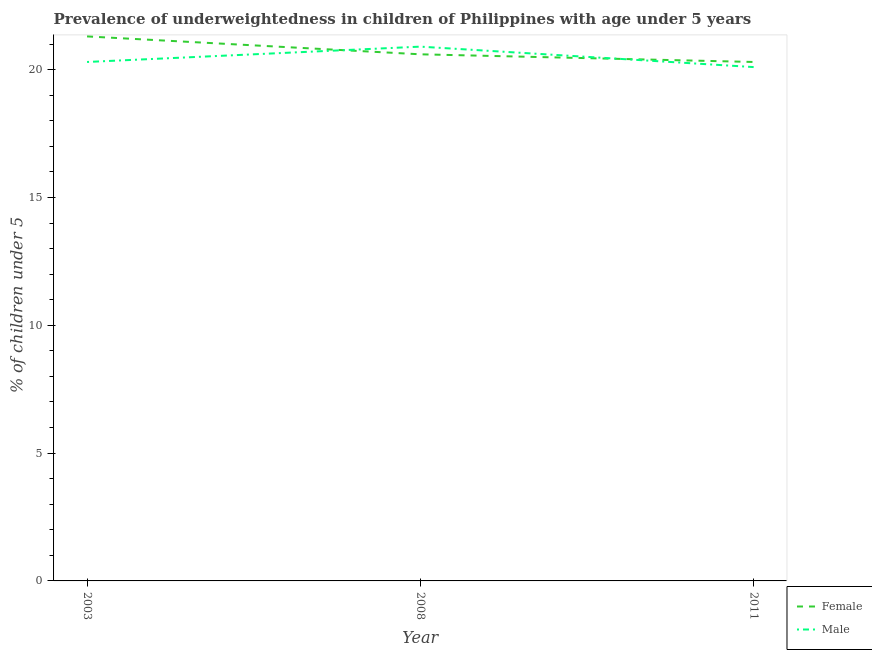How many different coloured lines are there?
Provide a short and direct response. 2. Does the line corresponding to percentage of underweighted female children intersect with the line corresponding to percentage of underweighted male children?
Your answer should be very brief. Yes. What is the percentage of underweighted female children in 2011?
Ensure brevity in your answer.  20.3. Across all years, what is the maximum percentage of underweighted female children?
Your answer should be compact. 21.3. Across all years, what is the minimum percentage of underweighted female children?
Your answer should be compact. 20.3. In which year was the percentage of underweighted female children maximum?
Your response must be concise. 2003. In which year was the percentage of underweighted female children minimum?
Your response must be concise. 2011. What is the total percentage of underweighted female children in the graph?
Give a very brief answer. 62.2. What is the difference between the percentage of underweighted male children in 2008 and that in 2011?
Provide a short and direct response. 0.8. What is the average percentage of underweighted female children per year?
Provide a succinct answer. 20.73. In the year 2008, what is the difference between the percentage of underweighted male children and percentage of underweighted female children?
Your response must be concise. 0.3. In how many years, is the percentage of underweighted female children greater than 19 %?
Your answer should be compact. 3. What is the ratio of the percentage of underweighted male children in 2003 to that in 2008?
Make the answer very short. 0.97. Is the difference between the percentage of underweighted female children in 2008 and 2011 greater than the difference between the percentage of underweighted male children in 2008 and 2011?
Provide a short and direct response. No. What is the difference between the highest and the second highest percentage of underweighted female children?
Provide a succinct answer. 0.7. What is the difference between the highest and the lowest percentage of underweighted female children?
Keep it short and to the point. 1. In how many years, is the percentage of underweighted male children greater than the average percentage of underweighted male children taken over all years?
Your answer should be very brief. 1. Is the sum of the percentage of underweighted male children in 2003 and 2011 greater than the maximum percentage of underweighted female children across all years?
Make the answer very short. Yes. Does the percentage of underweighted male children monotonically increase over the years?
Offer a terse response. No. Is the percentage of underweighted male children strictly greater than the percentage of underweighted female children over the years?
Your response must be concise. No. How many years are there in the graph?
Your response must be concise. 3. Are the values on the major ticks of Y-axis written in scientific E-notation?
Provide a short and direct response. No. Does the graph contain any zero values?
Your response must be concise. No. How many legend labels are there?
Ensure brevity in your answer.  2. What is the title of the graph?
Offer a very short reply. Prevalence of underweightedness in children of Philippines with age under 5 years. What is the label or title of the X-axis?
Keep it short and to the point. Year. What is the label or title of the Y-axis?
Make the answer very short.  % of children under 5. What is the  % of children under 5 of Female in 2003?
Make the answer very short. 21.3. What is the  % of children under 5 of Male in 2003?
Offer a terse response. 20.3. What is the  % of children under 5 of Female in 2008?
Provide a short and direct response. 20.6. What is the  % of children under 5 in Male in 2008?
Provide a succinct answer. 20.9. What is the  % of children under 5 in Female in 2011?
Offer a very short reply. 20.3. What is the  % of children under 5 in Male in 2011?
Your answer should be very brief. 20.1. Across all years, what is the maximum  % of children under 5 in Female?
Your answer should be very brief. 21.3. Across all years, what is the maximum  % of children under 5 in Male?
Provide a short and direct response. 20.9. Across all years, what is the minimum  % of children under 5 in Female?
Give a very brief answer. 20.3. Across all years, what is the minimum  % of children under 5 of Male?
Offer a very short reply. 20.1. What is the total  % of children under 5 of Female in the graph?
Ensure brevity in your answer.  62.2. What is the total  % of children under 5 of Male in the graph?
Your answer should be compact. 61.3. What is the difference between the  % of children under 5 in Female in 2003 and that in 2008?
Offer a very short reply. 0.7. What is the difference between the  % of children under 5 in Male in 2003 and that in 2008?
Make the answer very short. -0.6. What is the difference between the  % of children under 5 of Female in 2003 and that in 2011?
Your answer should be very brief. 1. What is the difference between the  % of children under 5 in Male in 2003 and that in 2011?
Your answer should be very brief. 0.2. What is the difference between the  % of children under 5 in Female in 2003 and the  % of children under 5 in Male in 2011?
Offer a very short reply. 1.2. What is the difference between the  % of children under 5 of Female in 2008 and the  % of children under 5 of Male in 2011?
Provide a succinct answer. 0.5. What is the average  % of children under 5 in Female per year?
Make the answer very short. 20.73. What is the average  % of children under 5 of Male per year?
Give a very brief answer. 20.43. In the year 2008, what is the difference between the  % of children under 5 in Female and  % of children under 5 in Male?
Provide a succinct answer. -0.3. In the year 2011, what is the difference between the  % of children under 5 in Female and  % of children under 5 in Male?
Offer a very short reply. 0.2. What is the ratio of the  % of children under 5 of Female in 2003 to that in 2008?
Your response must be concise. 1.03. What is the ratio of the  % of children under 5 of Male in 2003 to that in 2008?
Ensure brevity in your answer.  0.97. What is the ratio of the  % of children under 5 in Female in 2003 to that in 2011?
Your response must be concise. 1.05. What is the ratio of the  % of children under 5 of Female in 2008 to that in 2011?
Ensure brevity in your answer.  1.01. What is the ratio of the  % of children under 5 of Male in 2008 to that in 2011?
Make the answer very short. 1.04. What is the difference between the highest and the second highest  % of children under 5 in Female?
Provide a short and direct response. 0.7. What is the difference between the highest and the second highest  % of children under 5 of Male?
Ensure brevity in your answer.  0.6. What is the difference between the highest and the lowest  % of children under 5 of Male?
Offer a terse response. 0.8. 